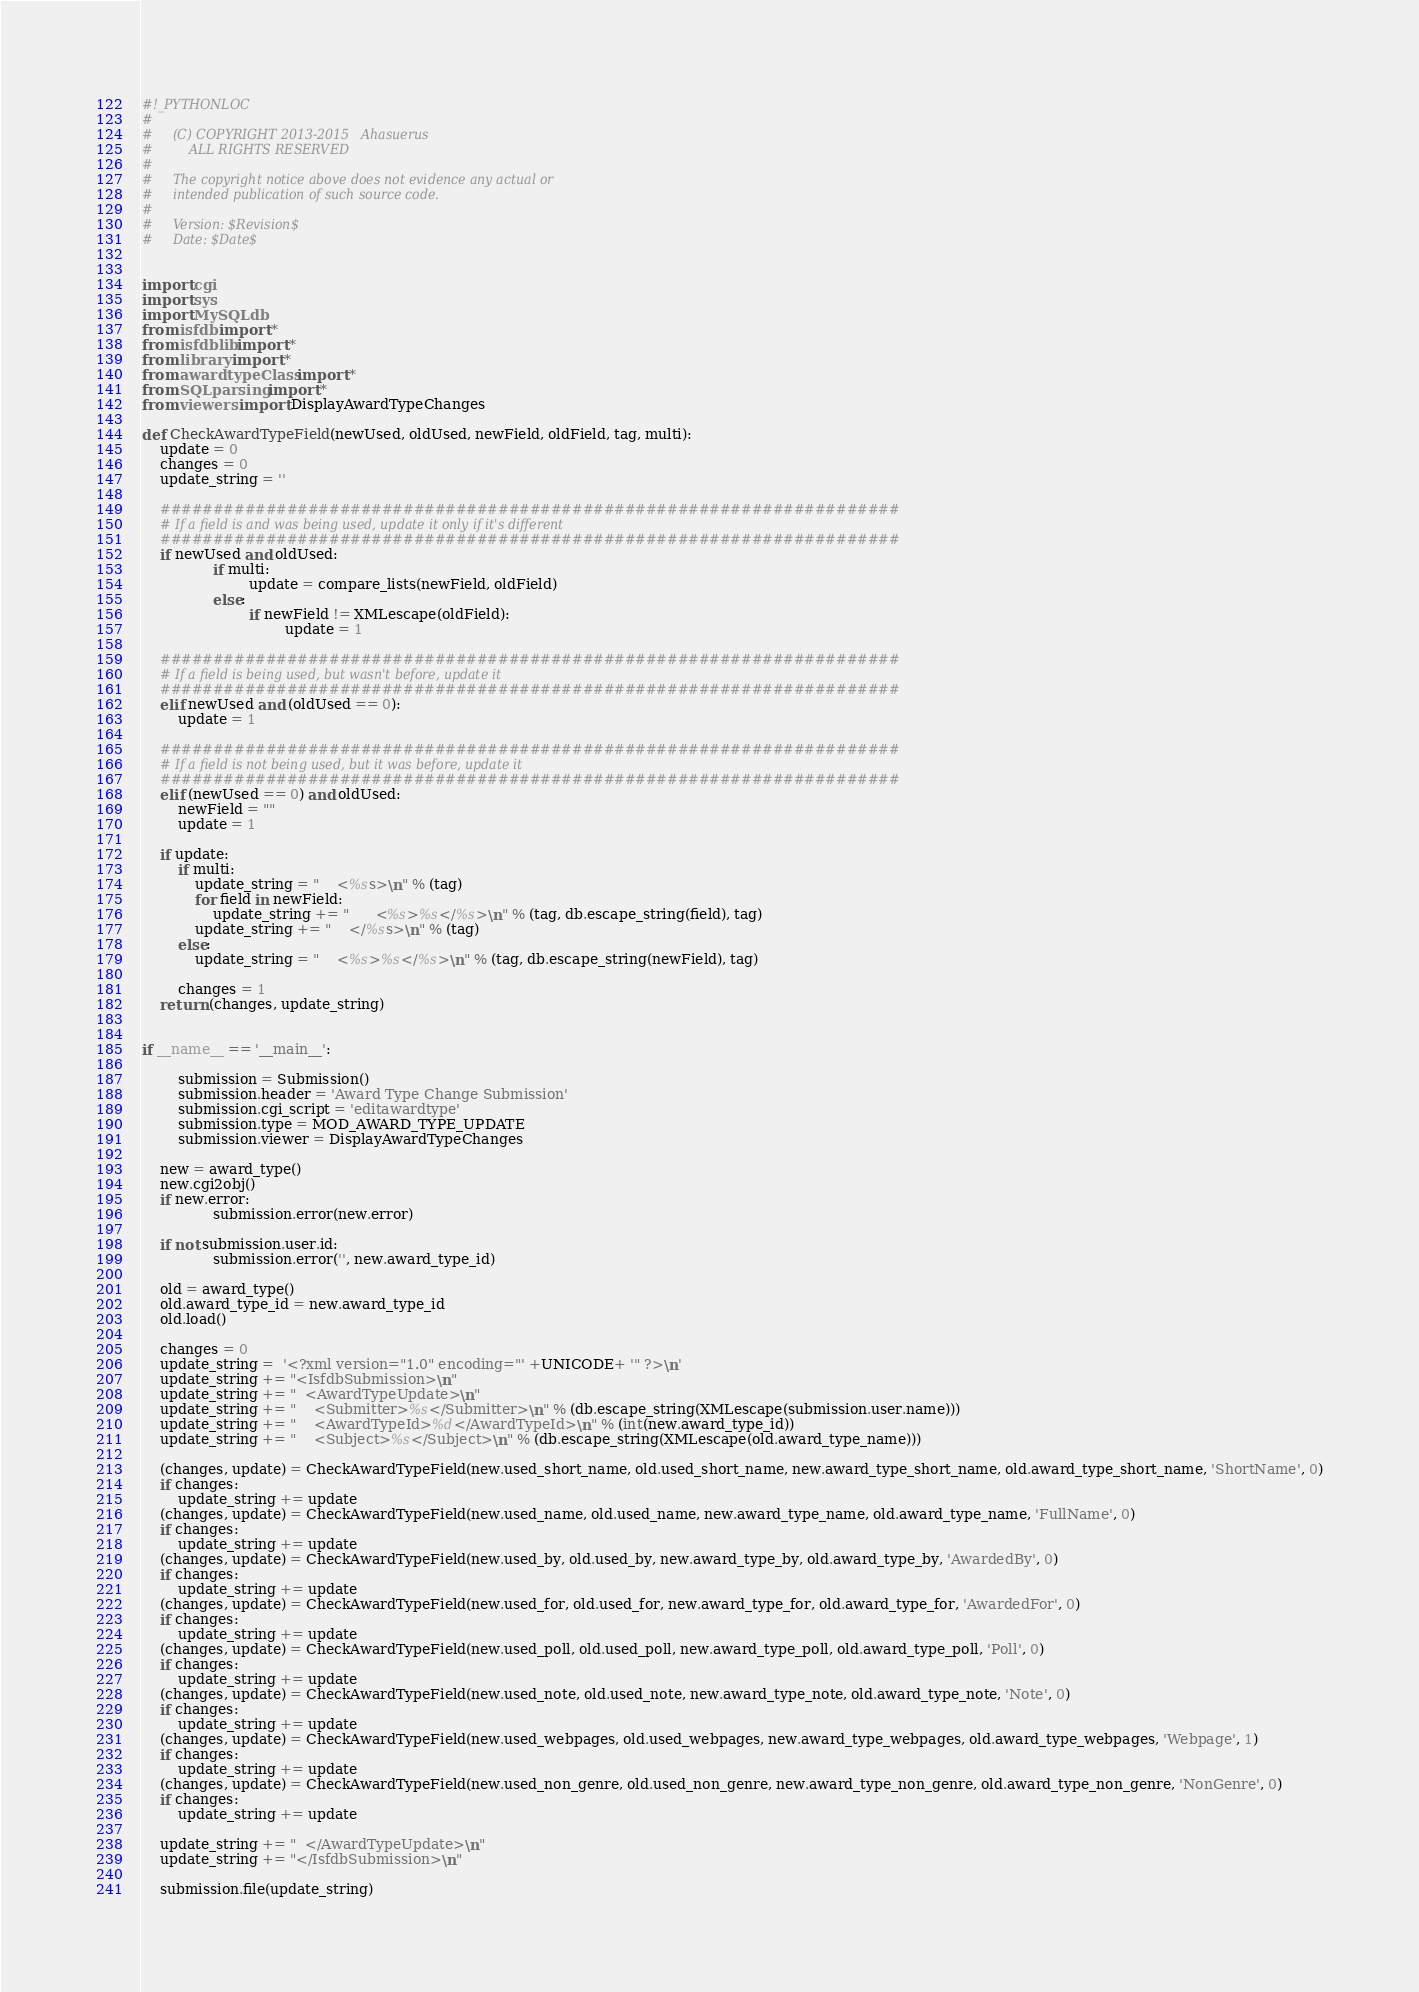Convert code to text. <code><loc_0><loc_0><loc_500><loc_500><_Python_>#!_PYTHONLOC
#
#     (C) COPYRIGHT 2013-2015   Ahasuerus
#         ALL RIGHTS RESERVED
#
#     The copyright notice above does not evidence any actual or
#     intended publication of such source code.
#
#     Version: $Revision$
#     Date: $Date$

	
import cgi
import sys
import MySQLdb
from isfdb import *
from isfdblib import *
from library import *
from awardtypeClass import *
from SQLparsing import *
from viewers import DisplayAwardTypeChanges
	
def CheckAwardTypeField(newUsed, oldUsed, newField, oldField, tag, multi):
	update = 0
	changes = 0
	update_string = ''

	######################################################################
	# If a field is and was being used, update it only if it's different
	######################################################################
	if newUsed and oldUsed:
                if multi:
                        update = compare_lists(newField, oldField)
                else:
                        if newField != XMLescape(oldField):
                                update = 1

	######################################################################
	# If a field is being used, but wasn't before, update it
	######################################################################
	elif newUsed and (oldUsed == 0):
		update = 1

	######################################################################
	# If a field is not being used, but it was before, update it
	######################################################################
	elif (newUsed == 0) and oldUsed:
		newField = ""
		update = 1

	if update:
		if multi:
			update_string = "    <%ss>\n" % (tag)
			for field in newField:
				update_string += "      <%s>%s</%s>\n" % (tag, db.escape_string(field), tag)
			update_string += "    </%ss>\n" % (tag)
		else:
			update_string = "    <%s>%s</%s>\n" % (tag, db.escape_string(newField), tag)

		changes = 1
	return (changes, update_string)


if __name__ == '__main__':

        submission = Submission()
        submission.header = 'Award Type Change Submission'
        submission.cgi_script = 'editawardtype'
        submission.type = MOD_AWARD_TYPE_UPDATE
        submission.viewer = DisplayAwardTypeChanges

	new = award_type()
	new.cgi2obj()
	if new.error:
                submission.error(new.error)

	if not submission.user.id:
                submission.error('', new.award_type_id)
	
	old = award_type()
	old.award_type_id = new.award_type_id
	old.load()
	
	changes = 0
	update_string =  '<?xml version="1.0" encoding="' +UNICODE+ '" ?>\n'
	update_string += "<IsfdbSubmission>\n"
	update_string += "  <AwardTypeUpdate>\n"
	update_string += "    <Submitter>%s</Submitter>\n" % (db.escape_string(XMLescape(submission.user.name)))
	update_string += "    <AwardTypeId>%d</AwardTypeId>\n" % (int(new.award_type_id))
	update_string += "    <Subject>%s</Subject>\n" % (db.escape_string(XMLescape(old.award_type_name)))
	
	(changes, update) = CheckAwardTypeField(new.used_short_name, old.used_short_name, new.award_type_short_name, old.award_type_short_name, 'ShortName', 0)
	if changes:
		update_string += update
	(changes, update) = CheckAwardTypeField(new.used_name, old.used_name, new.award_type_name, old.award_type_name, 'FullName', 0)
	if changes:
		update_string += update
	(changes, update) = CheckAwardTypeField(new.used_by, old.used_by, new.award_type_by, old.award_type_by, 'AwardedBy', 0)
	if changes:
		update_string += update
	(changes, update) = CheckAwardTypeField(new.used_for, old.used_for, new.award_type_for, old.award_type_for, 'AwardedFor', 0)
	if changes:
		update_string += update
	(changes, update) = CheckAwardTypeField(new.used_poll, old.used_poll, new.award_type_poll, old.award_type_poll, 'Poll', 0)
	if changes:
		update_string += update
	(changes, update) = CheckAwardTypeField(new.used_note, old.used_note, new.award_type_note, old.award_type_note, 'Note', 0)
	if changes:
		update_string += update
	(changes, update) = CheckAwardTypeField(new.used_webpages, old.used_webpages, new.award_type_webpages, old.award_type_webpages, 'Webpage', 1)
	if changes:
		update_string += update
	(changes, update) = CheckAwardTypeField(new.used_non_genre, old.used_non_genre, new.award_type_non_genre, old.award_type_non_genre, 'NonGenre', 0)
	if changes:
		update_string += update
	
	update_string += "  </AwardTypeUpdate>\n"
	update_string += "</IsfdbSubmission>\n"
	
	submission.file(update_string)
</code> 